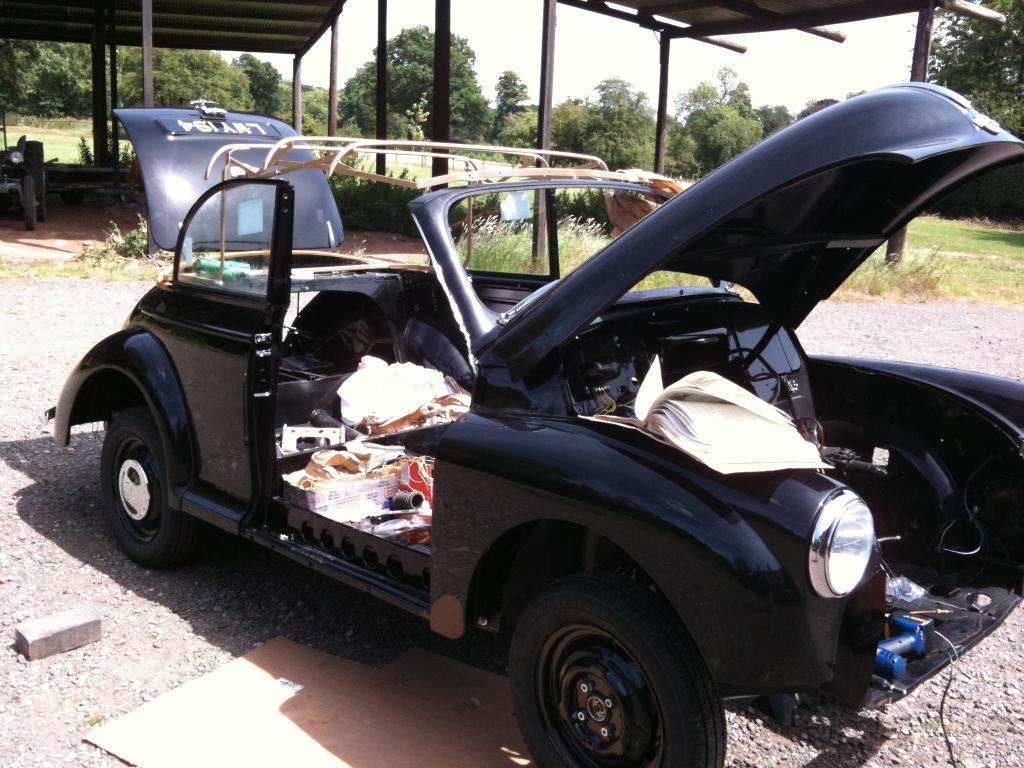In one or two sentences, can you explain what this image depicts? In this image I can see a black colour vehicle, a book and few other stuffs over here. In the background I can see bushes, grass, number of trees, shades and one more vehicle over there. 